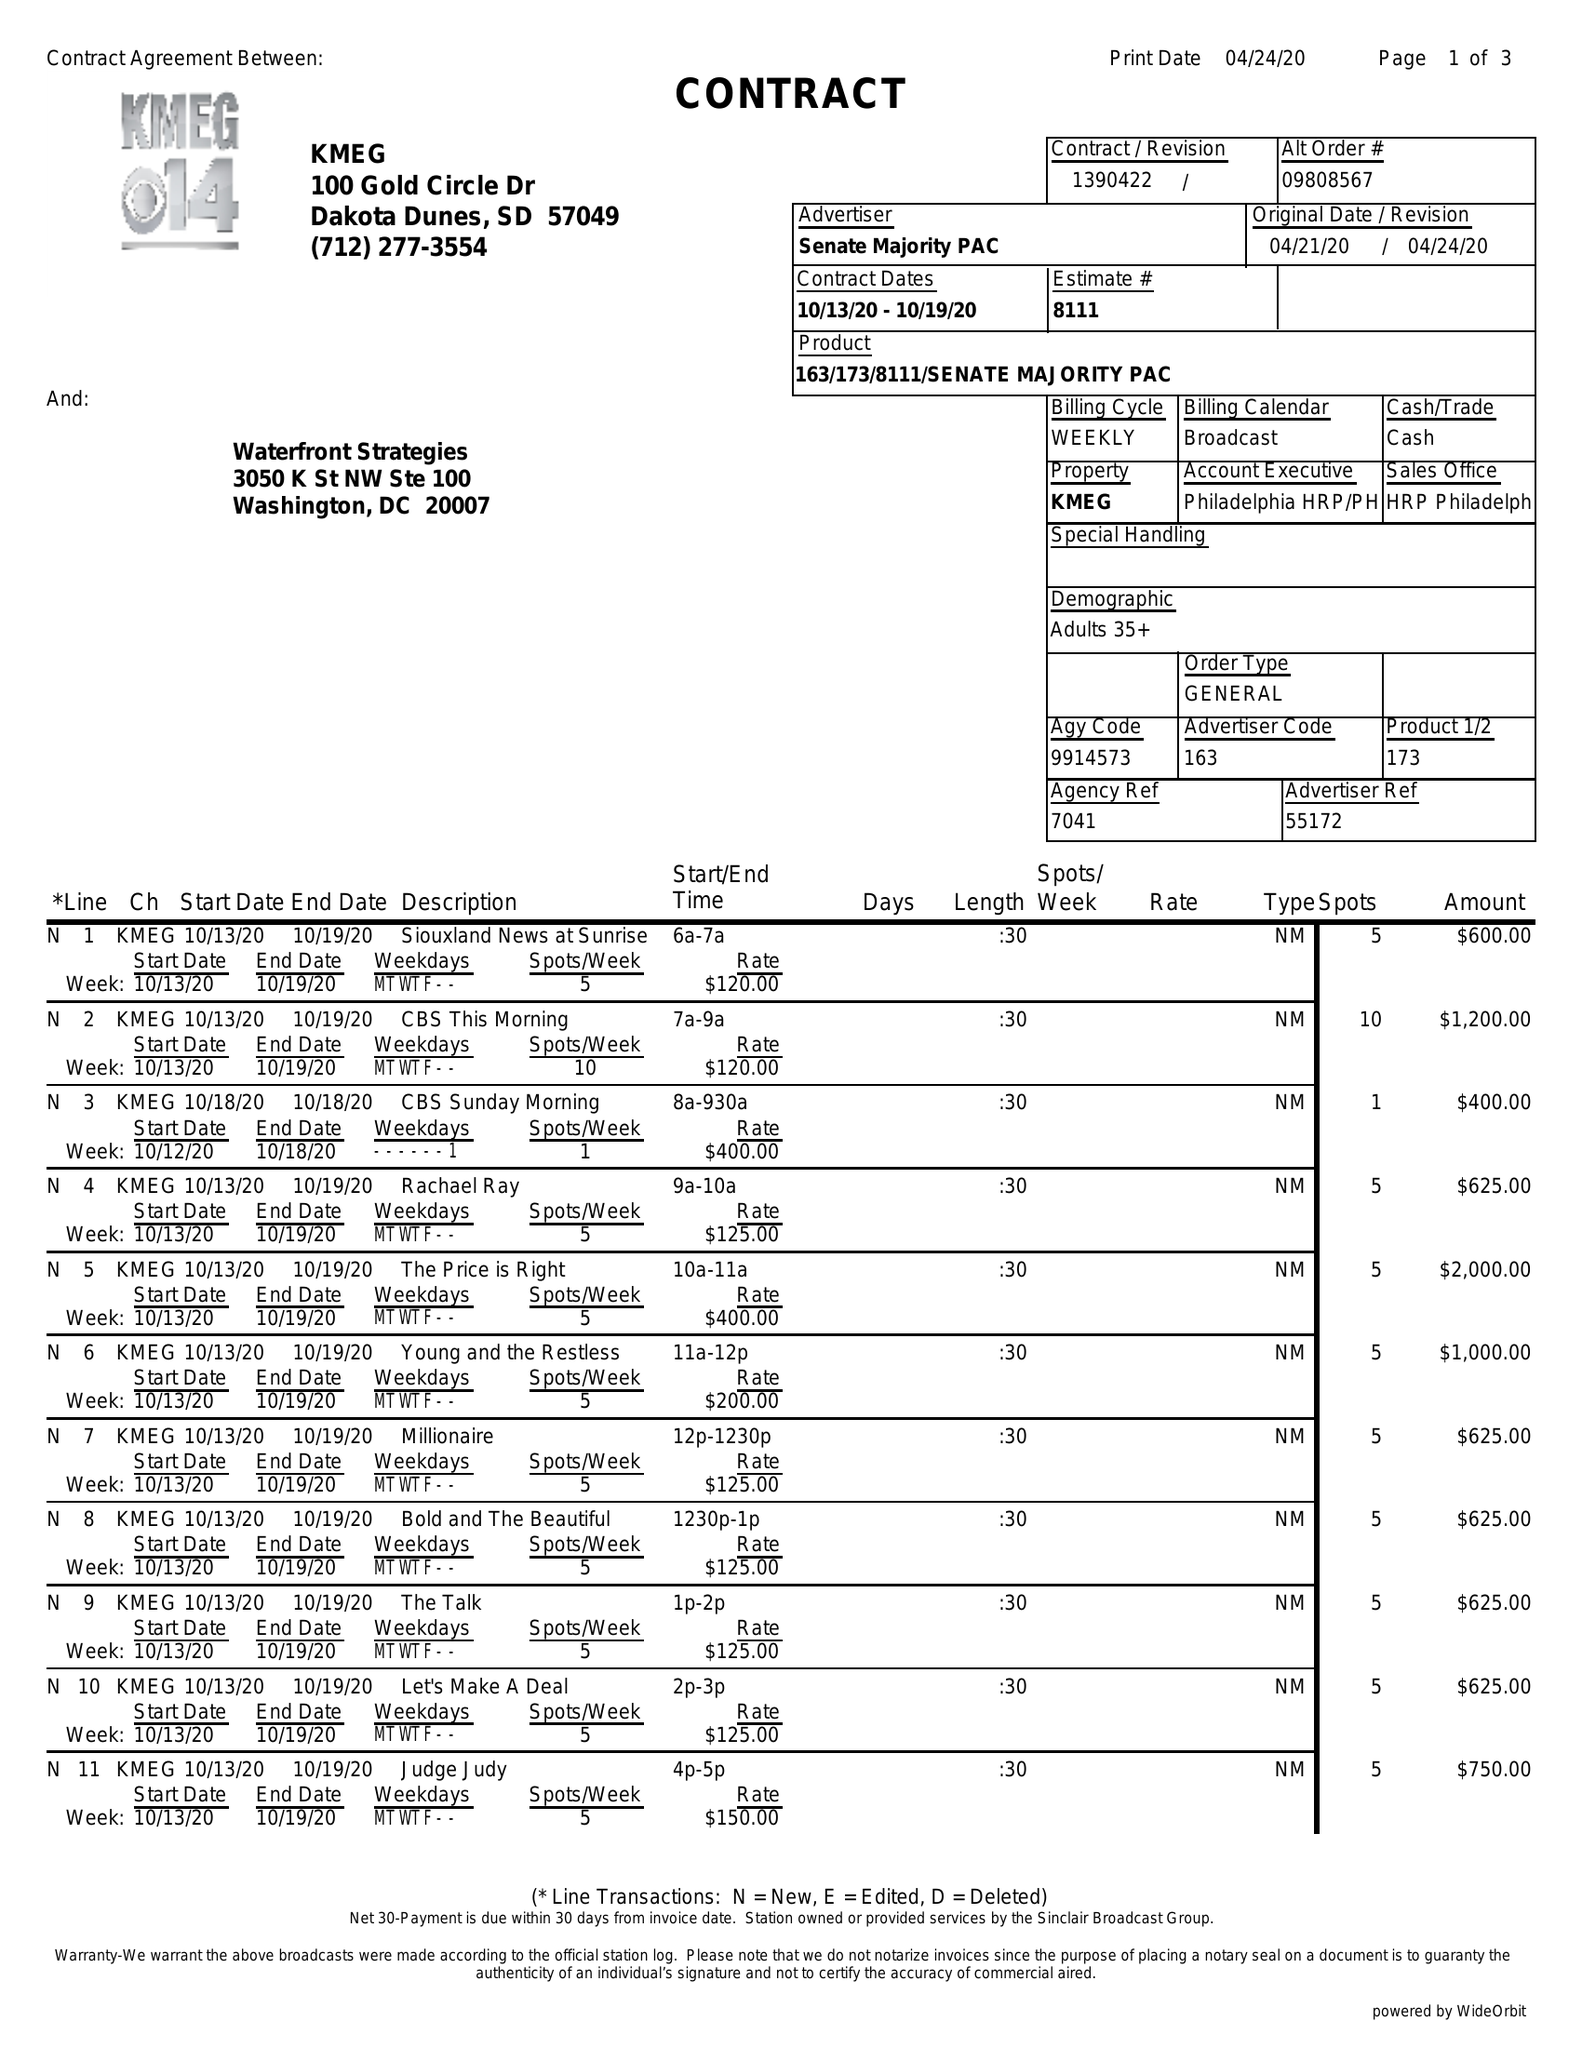What is the value for the flight_to?
Answer the question using a single word or phrase. 10/19/20 